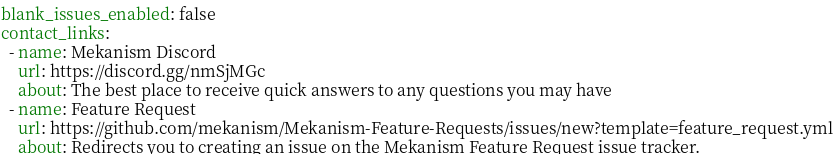Convert code to text. <code><loc_0><loc_0><loc_500><loc_500><_YAML_>blank_issues_enabled: false
contact_links:
  - name: Mekanism Discord
    url: https://discord.gg/nmSjMGc
    about: The best place to receive quick answers to any questions you may have
  - name: Feature Request
    url: https://github.com/mekanism/Mekanism-Feature-Requests/issues/new?template=feature_request.yml
    about: Redirects you to creating an issue on the Mekanism Feature Request issue tracker.</code> 